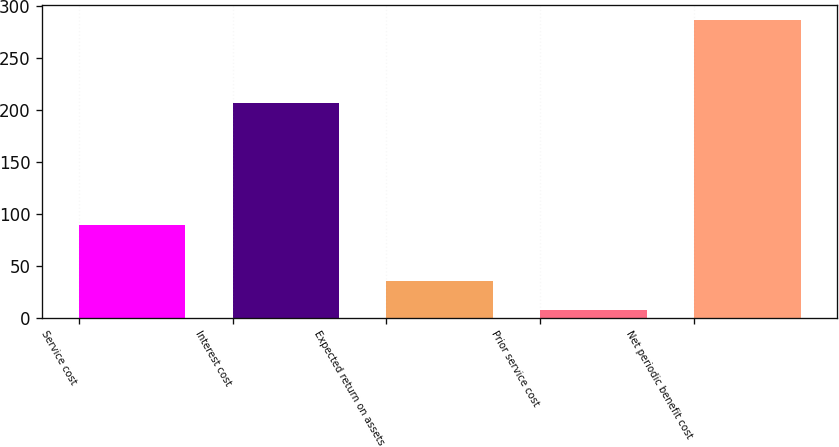Convert chart. <chart><loc_0><loc_0><loc_500><loc_500><bar_chart><fcel>Service cost<fcel>Interest cost<fcel>Expected return on assets<fcel>Prior service cost<fcel>Net periodic benefit cost<nl><fcel>89<fcel>207<fcel>35<fcel>7<fcel>287<nl></chart> 